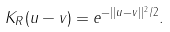Convert formula to latex. <formula><loc_0><loc_0><loc_500><loc_500>K _ { R } ( u - v ) = e ^ { - | | u - v | | ^ { 2 } / 2 } .</formula> 